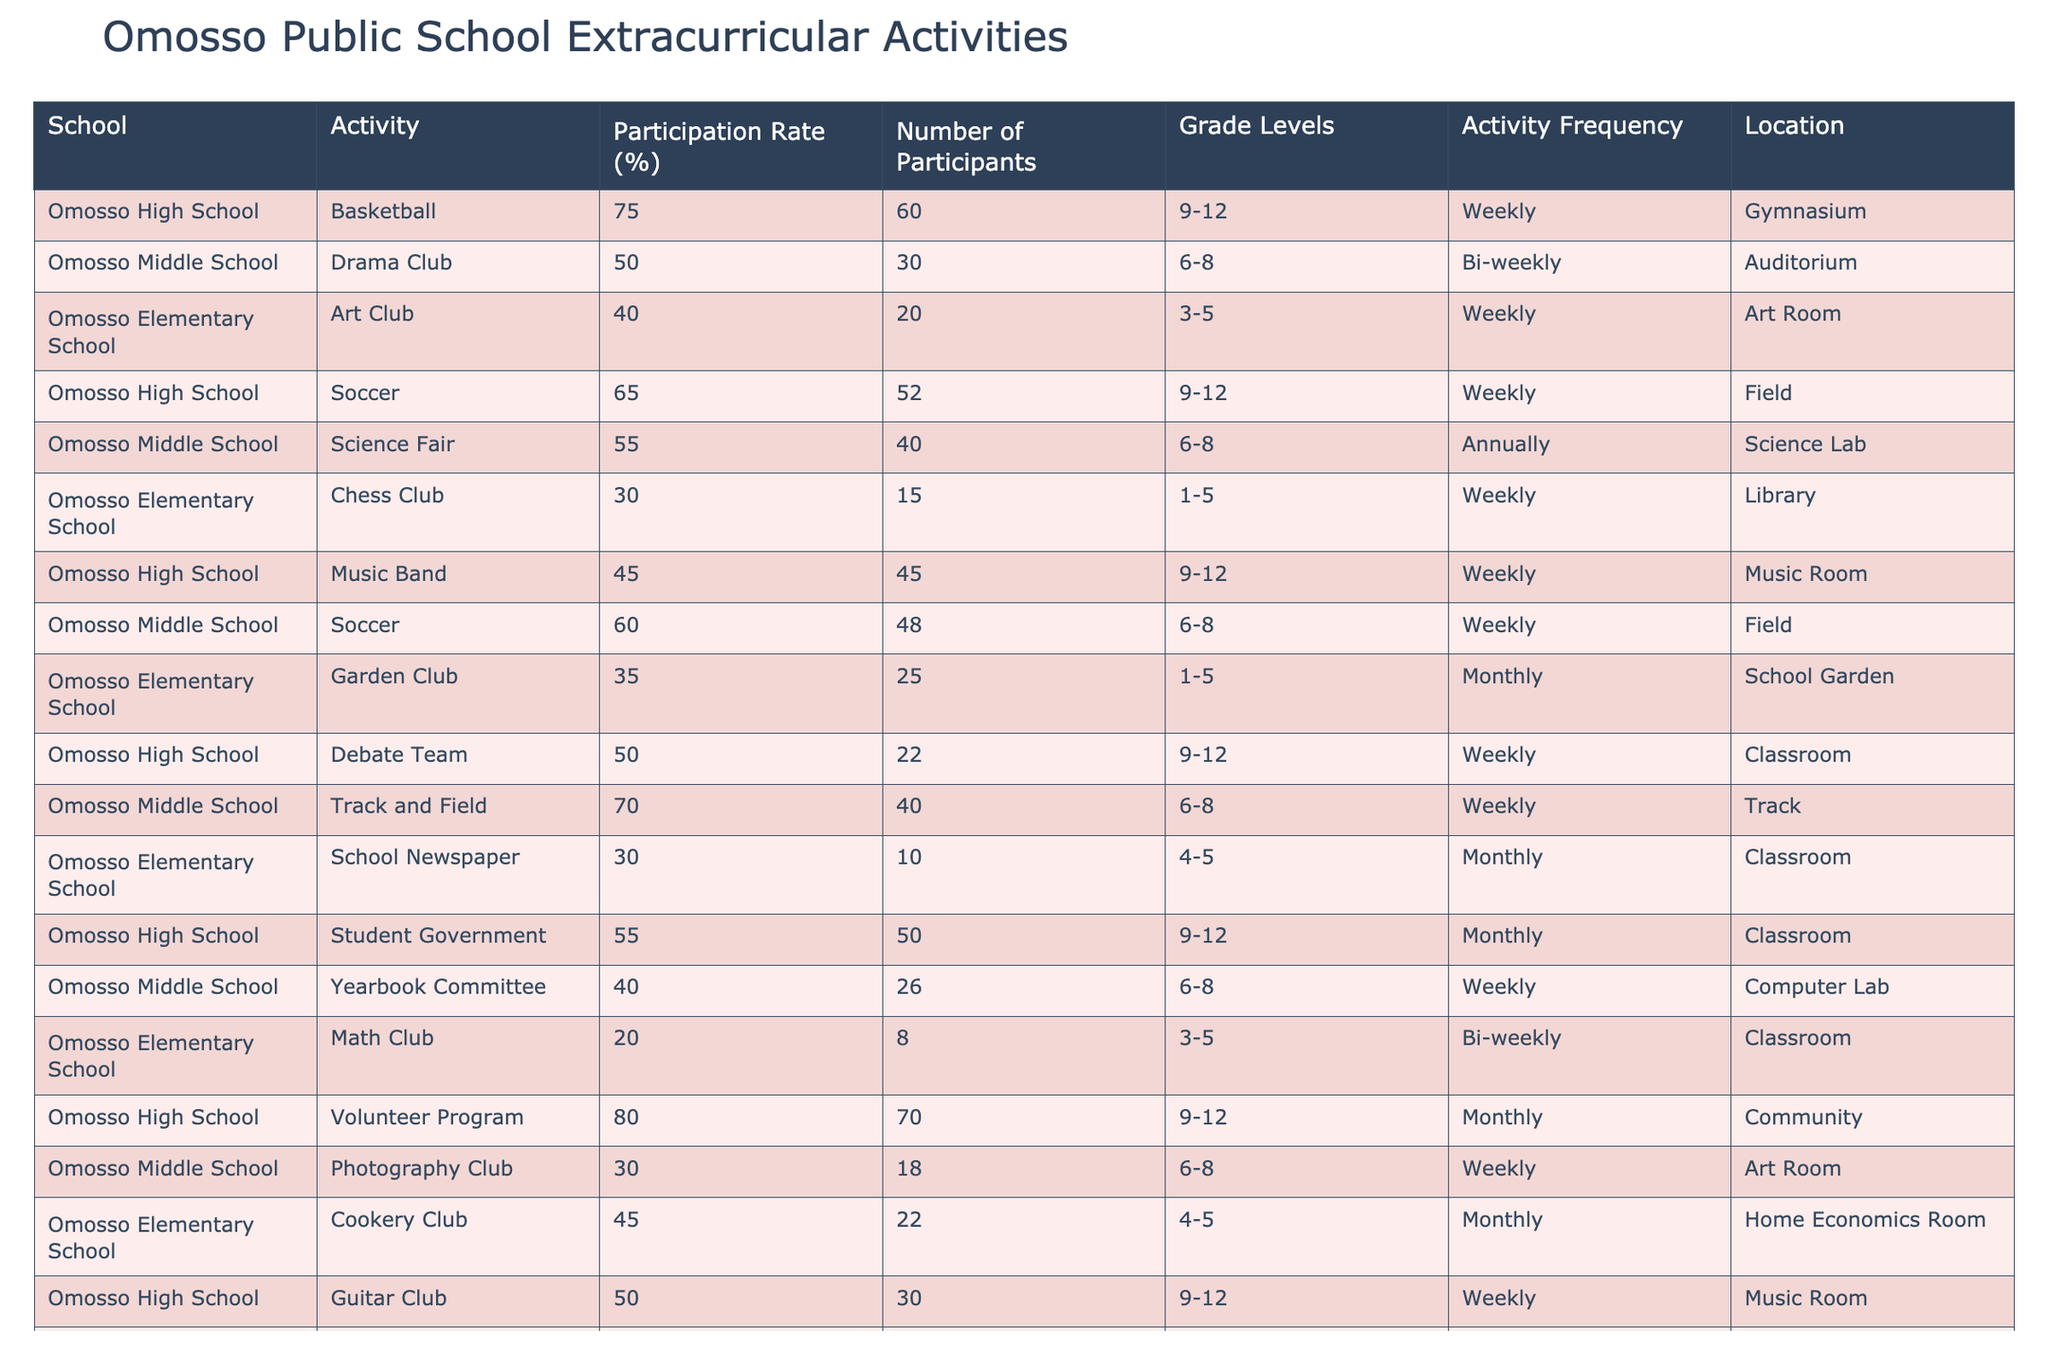What is the participation rate for the Basketball activity at Omosso High School? The participation rate is explicitly listed in the table for the Basketball activity, which is stated to be 75%.
Answer: 75% Which extracurricular activity has the highest number of participants? By reviewing the 'Number of Participants' column, the Volunteer Program at Omosso High School has the highest number with 70 participants.
Answer: 70 Is the Art Club at Omosso Elementary School held weekly? The table indicates that the Art Club happens weekly, confirming that its frequency is indeed weekly.
Answer: Yes What is the average participation rate for activities in Omosso Middle School? The participation rates for Middle School activities are 50, 55, 60, 70, and 40. Summing these gives 275, and there are 5 activities, so the average is 275/5 = 55%.
Answer: 55% How many participants are involved in the Science Fair and Track and Field activities combined at Omosso Middle School? The Science Fair has 40 participants, and Track and Field has 40 participants as well. Adding these gives 40 + 40 = 80 participants in total.
Answer: 80 Which schools offer the Reader's Club and the Chess Club? The Reader's Club is at Omosso Elementary School, and Chess Club is also at Omosso Elementary School, as both are listed in the table.
Answer: Omosso Elementary School Is the Music Band activity at Omosso High School more popular than the Drama Club at Omosso Middle School in terms of participation rate? The participation rate for the Music Band at Omosso High School is 45%, while the Drama Club at Omosso Middle School is at 50%. Since 50% is higher than 45%, it is less popular.
Answer: No What percentage of students participate in the Volunteer Program in Omosso High School compared to the Soccer team at the same school? The Volunteer Program has a participation rate of 80% while the Soccer team has a rate of 65%. To compare, we see that 80% is greater than 65%, indicating more participation.
Answer: 80% vs 65% If you sum the participation rates of all activities at Omosso Elementary School, what is the total participation rate? The participation rates for the elementary activities are 40, 30, 35, 20, and 45. Adding these gives 40 + 30 + 35 + 20 + 45 = 170.
Answer: 170 Are there any extracurricular activities in Omosso High School that are held monthly? The table shows Student Government and Volunteer Program at Omosso High School are both designated as monthly activities.
Answer: Yes What is the difference in participation rate between the most popular activity and the least popular activity in Omosso High School? The Volunteer Program has the highest rate at 80%, while the Math Club has the lowest at 20%. The difference is calculated as 80 - 20 = 60.
Answer: 60 